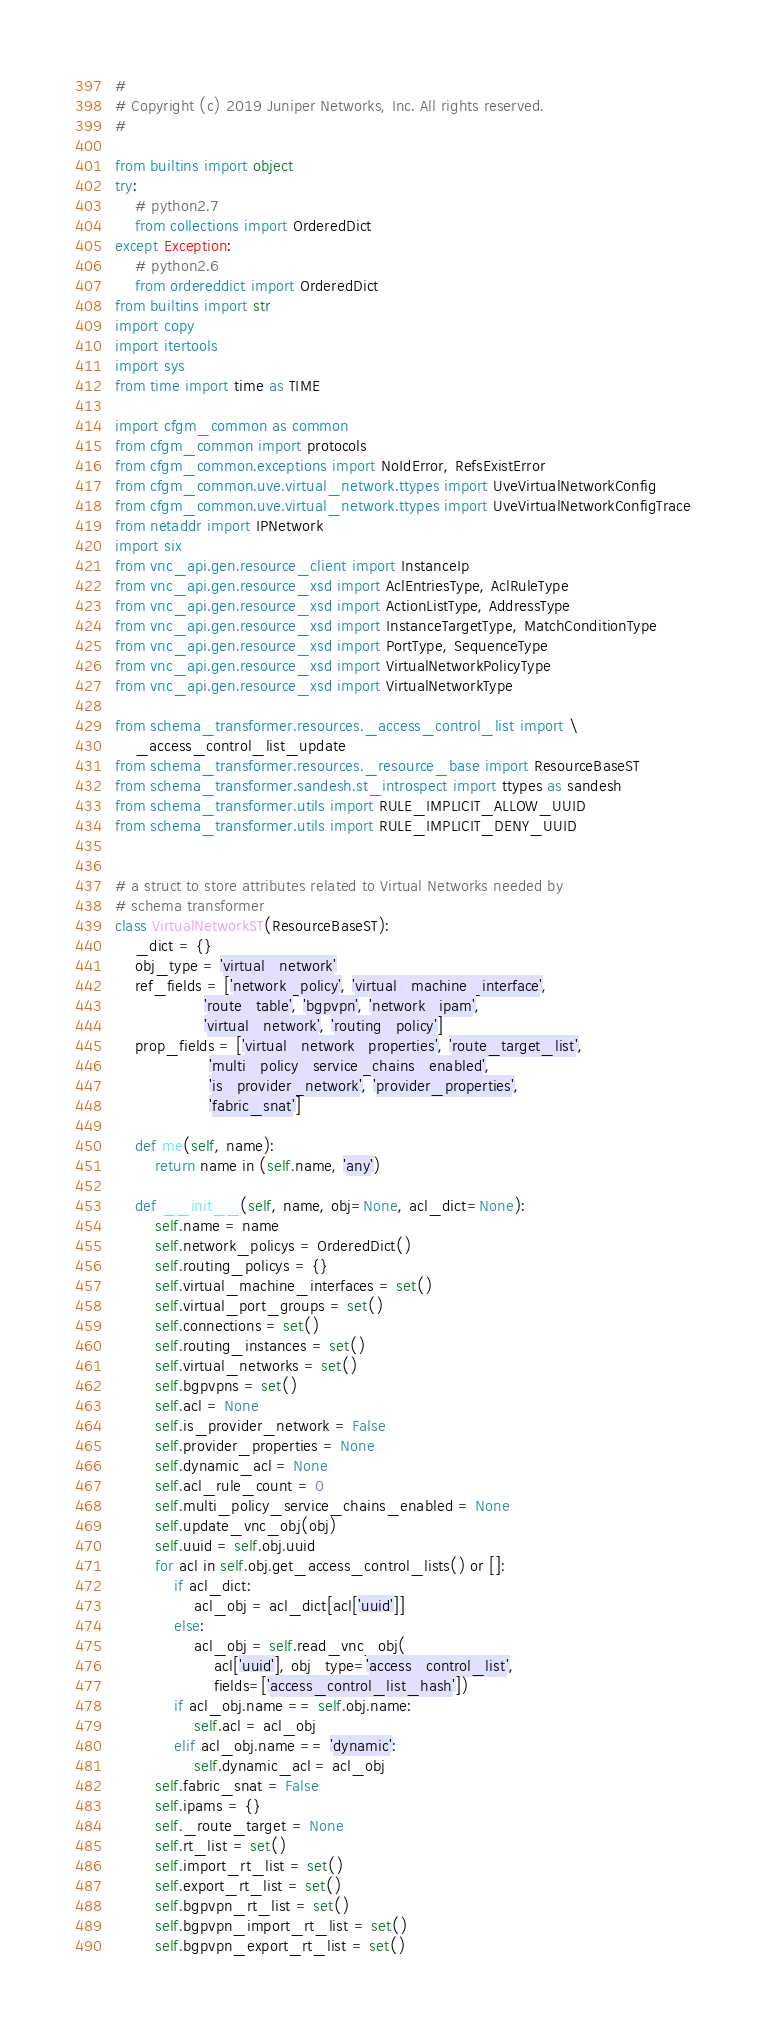Convert code to text. <code><loc_0><loc_0><loc_500><loc_500><_Python_>#
# Copyright (c) 2019 Juniper Networks, Inc. All rights reserved.
#

from builtins import object
try:
    # python2.7
    from collections import OrderedDict
except Exception:
    # python2.6
    from ordereddict import OrderedDict
from builtins import str
import copy
import itertools
import sys
from time import time as TIME

import cfgm_common as common
from cfgm_common import protocols
from cfgm_common.exceptions import NoIdError, RefsExistError
from cfgm_common.uve.virtual_network.ttypes import UveVirtualNetworkConfig
from cfgm_common.uve.virtual_network.ttypes import UveVirtualNetworkConfigTrace
from netaddr import IPNetwork
import six
from vnc_api.gen.resource_client import InstanceIp
from vnc_api.gen.resource_xsd import AclEntriesType, AclRuleType
from vnc_api.gen.resource_xsd import ActionListType, AddressType
from vnc_api.gen.resource_xsd import InstanceTargetType, MatchConditionType
from vnc_api.gen.resource_xsd import PortType, SequenceType
from vnc_api.gen.resource_xsd import VirtualNetworkPolicyType
from vnc_api.gen.resource_xsd import VirtualNetworkType

from schema_transformer.resources._access_control_list import \
    _access_control_list_update
from schema_transformer.resources._resource_base import ResourceBaseST
from schema_transformer.sandesh.st_introspect import ttypes as sandesh
from schema_transformer.utils import RULE_IMPLICIT_ALLOW_UUID
from schema_transformer.utils import RULE_IMPLICIT_DENY_UUID


# a struct to store attributes related to Virtual Networks needed by
# schema transformer
class VirtualNetworkST(ResourceBaseST):
    _dict = {}
    obj_type = 'virtual_network'
    ref_fields = ['network_policy', 'virtual_machine_interface',
                  'route_table', 'bgpvpn', 'network_ipam',
                  'virtual_network', 'routing_policy']
    prop_fields = ['virtual_network_properties', 'route_target_list',
                   'multi_policy_service_chains_enabled',
                   'is_provider_network', 'provider_properties',
                   'fabric_snat']

    def me(self, name):
        return name in (self.name, 'any')

    def __init__(self, name, obj=None, acl_dict=None):
        self.name = name
        self.network_policys = OrderedDict()
        self.routing_policys = {}
        self.virtual_machine_interfaces = set()
        self.virtual_port_groups = set()
        self.connections = set()
        self.routing_instances = set()
        self.virtual_networks = set()
        self.bgpvpns = set()
        self.acl = None
        self.is_provider_network = False
        self.provider_properties = None
        self.dynamic_acl = None
        self.acl_rule_count = 0
        self.multi_policy_service_chains_enabled = None
        self.update_vnc_obj(obj)
        self.uuid = self.obj.uuid
        for acl in self.obj.get_access_control_lists() or []:
            if acl_dict:
                acl_obj = acl_dict[acl['uuid']]
            else:
                acl_obj = self.read_vnc_obj(
                    acl['uuid'], obj_type='access_control_list',
                    fields=['access_control_list_hash'])
            if acl_obj.name == self.obj.name:
                self.acl = acl_obj
            elif acl_obj.name == 'dynamic':
                self.dynamic_acl = acl_obj
        self.fabric_snat = False
        self.ipams = {}
        self._route_target = None
        self.rt_list = set()
        self.import_rt_list = set()
        self.export_rt_list = set()
        self.bgpvpn_rt_list = set()
        self.bgpvpn_import_rt_list = set()
        self.bgpvpn_export_rt_list = set()</code> 